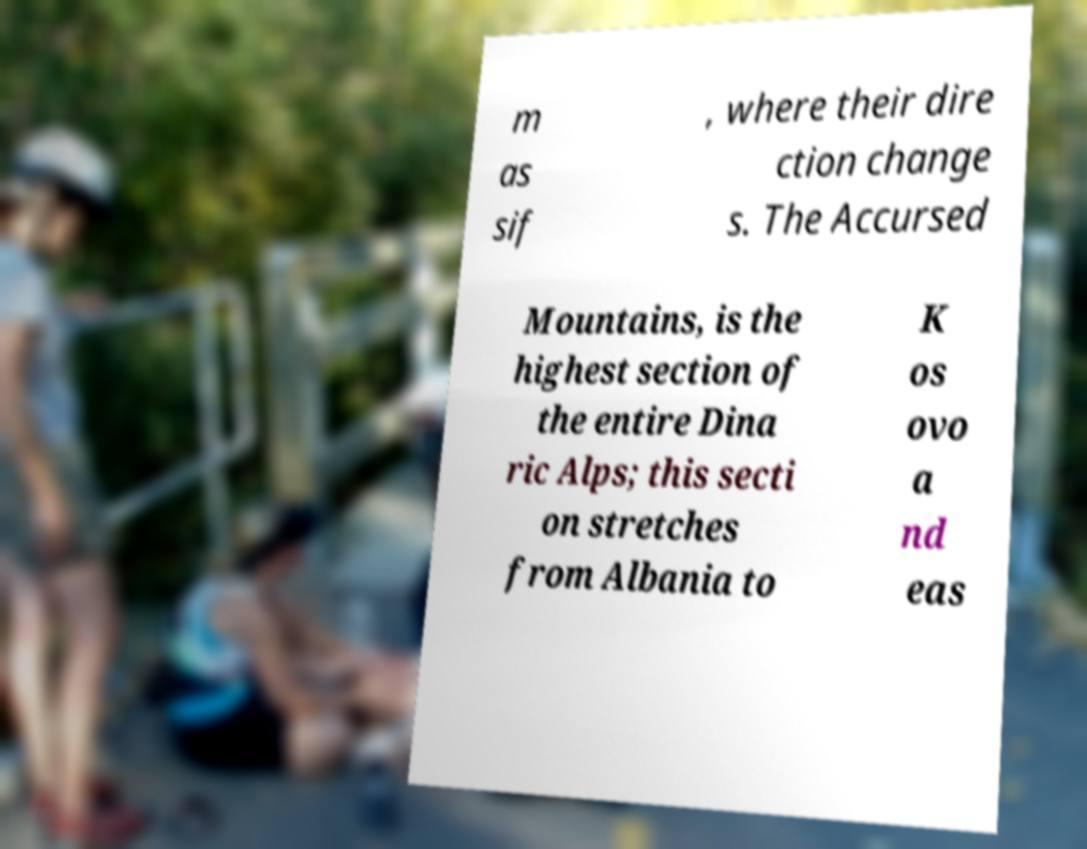Please identify and transcribe the text found in this image. m as sif , where their dire ction change s. The Accursed Mountains, is the highest section of the entire Dina ric Alps; this secti on stretches from Albania to K os ovo a nd eas 